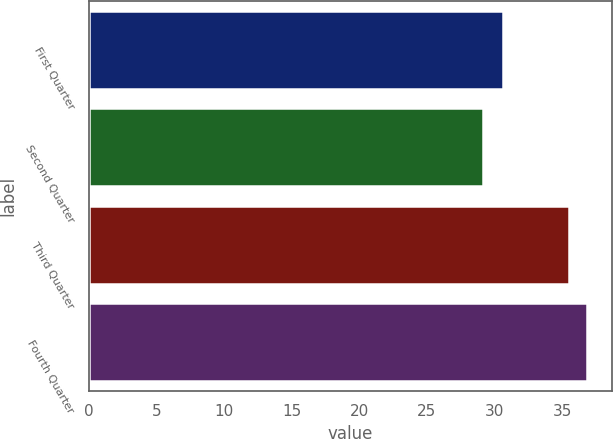Convert chart to OTSL. <chart><loc_0><loc_0><loc_500><loc_500><bar_chart><fcel>First Quarter<fcel>Second Quarter<fcel>Third Quarter<fcel>Fourth Quarter<nl><fcel>30.6<fcel>29.17<fcel>35.49<fcel>36.84<nl></chart> 